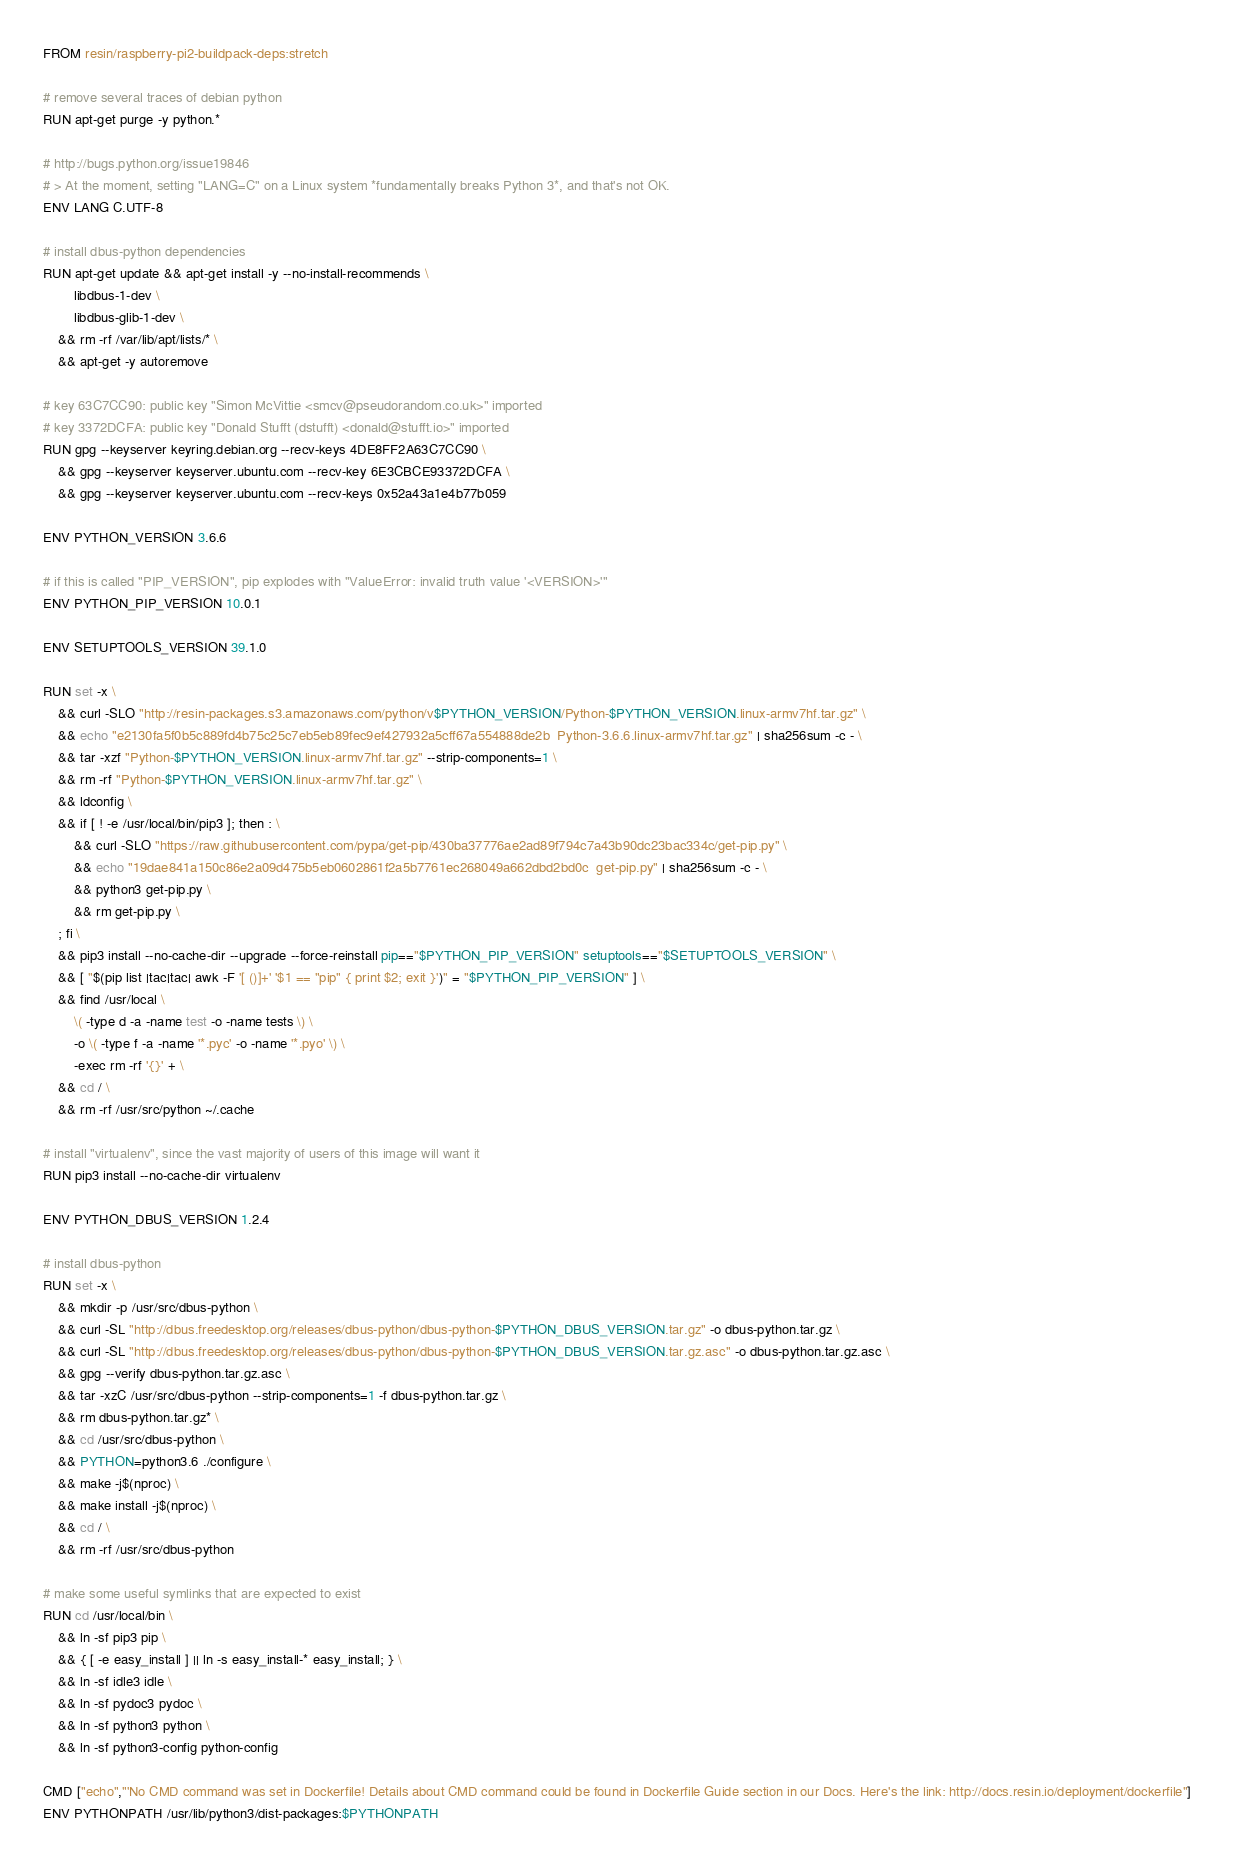Convert code to text. <code><loc_0><loc_0><loc_500><loc_500><_Dockerfile_>FROM resin/raspberry-pi2-buildpack-deps:stretch

# remove several traces of debian python
RUN apt-get purge -y python.*

# http://bugs.python.org/issue19846
# > At the moment, setting "LANG=C" on a Linux system *fundamentally breaks Python 3*, and that's not OK.
ENV LANG C.UTF-8

# install dbus-python dependencies 
RUN apt-get update && apt-get install -y --no-install-recommends \
		libdbus-1-dev \
		libdbus-glib-1-dev \
	&& rm -rf /var/lib/apt/lists/* \
	&& apt-get -y autoremove

# key 63C7CC90: public key "Simon McVittie <smcv@pseudorandom.co.uk>" imported
# key 3372DCFA: public key "Donald Stufft (dstufft) <donald@stufft.io>" imported
RUN gpg --keyserver keyring.debian.org --recv-keys 4DE8FF2A63C7CC90 \
	&& gpg --keyserver keyserver.ubuntu.com --recv-key 6E3CBCE93372DCFA \
	&& gpg --keyserver keyserver.ubuntu.com --recv-keys 0x52a43a1e4b77b059

ENV PYTHON_VERSION 3.6.6

# if this is called "PIP_VERSION", pip explodes with "ValueError: invalid truth value '<VERSION>'"
ENV PYTHON_PIP_VERSION 10.0.1

ENV SETUPTOOLS_VERSION 39.1.0

RUN set -x \
	&& curl -SLO "http://resin-packages.s3.amazonaws.com/python/v$PYTHON_VERSION/Python-$PYTHON_VERSION.linux-armv7hf.tar.gz" \
	&& echo "e2130fa5f0b5c889fd4b75c25c7eb5eb89fec9ef427932a5cff67a554888de2b  Python-3.6.6.linux-armv7hf.tar.gz" | sha256sum -c - \
	&& tar -xzf "Python-$PYTHON_VERSION.linux-armv7hf.tar.gz" --strip-components=1 \
	&& rm -rf "Python-$PYTHON_VERSION.linux-armv7hf.tar.gz" \
	&& ldconfig \
	&& if [ ! -e /usr/local/bin/pip3 ]; then : \
		&& curl -SLO "https://raw.githubusercontent.com/pypa/get-pip/430ba37776ae2ad89f794c7a43b90dc23bac334c/get-pip.py" \
		&& echo "19dae841a150c86e2a09d475b5eb0602861f2a5b7761ec268049a662dbd2bd0c  get-pip.py" | sha256sum -c - \
		&& python3 get-pip.py \
		&& rm get-pip.py \
	; fi \
	&& pip3 install --no-cache-dir --upgrade --force-reinstall pip=="$PYTHON_PIP_VERSION" setuptools=="$SETUPTOOLS_VERSION" \
	&& [ "$(pip list |tac|tac| awk -F '[ ()]+' '$1 == "pip" { print $2; exit }')" = "$PYTHON_PIP_VERSION" ] \
	&& find /usr/local \
		\( -type d -a -name test -o -name tests \) \
		-o \( -type f -a -name '*.pyc' -o -name '*.pyo' \) \
		-exec rm -rf '{}' + \
	&& cd / \
	&& rm -rf /usr/src/python ~/.cache

# install "virtualenv", since the vast majority of users of this image will want it
RUN pip3 install --no-cache-dir virtualenv

ENV PYTHON_DBUS_VERSION 1.2.4

# install dbus-python
RUN set -x \
	&& mkdir -p /usr/src/dbus-python \
	&& curl -SL "http://dbus.freedesktop.org/releases/dbus-python/dbus-python-$PYTHON_DBUS_VERSION.tar.gz" -o dbus-python.tar.gz \
	&& curl -SL "http://dbus.freedesktop.org/releases/dbus-python/dbus-python-$PYTHON_DBUS_VERSION.tar.gz.asc" -o dbus-python.tar.gz.asc \
	&& gpg --verify dbus-python.tar.gz.asc \
	&& tar -xzC /usr/src/dbus-python --strip-components=1 -f dbus-python.tar.gz \
	&& rm dbus-python.tar.gz* \
	&& cd /usr/src/dbus-python \
	&& PYTHON=python3.6 ./configure \
	&& make -j$(nproc) \
	&& make install -j$(nproc) \
	&& cd / \
	&& rm -rf /usr/src/dbus-python

# make some useful symlinks that are expected to exist
RUN cd /usr/local/bin \
	&& ln -sf pip3 pip \
	&& { [ -e easy_install ] || ln -s easy_install-* easy_install; } \
	&& ln -sf idle3 idle \
	&& ln -sf pydoc3 pydoc \
	&& ln -sf python3 python \
	&& ln -sf python3-config python-config

CMD ["echo","'No CMD command was set in Dockerfile! Details about CMD command could be found in Dockerfile Guide section in our Docs. Here's the link: http://docs.resin.io/deployment/dockerfile"]
ENV PYTHONPATH /usr/lib/python3/dist-packages:$PYTHONPATH
</code> 